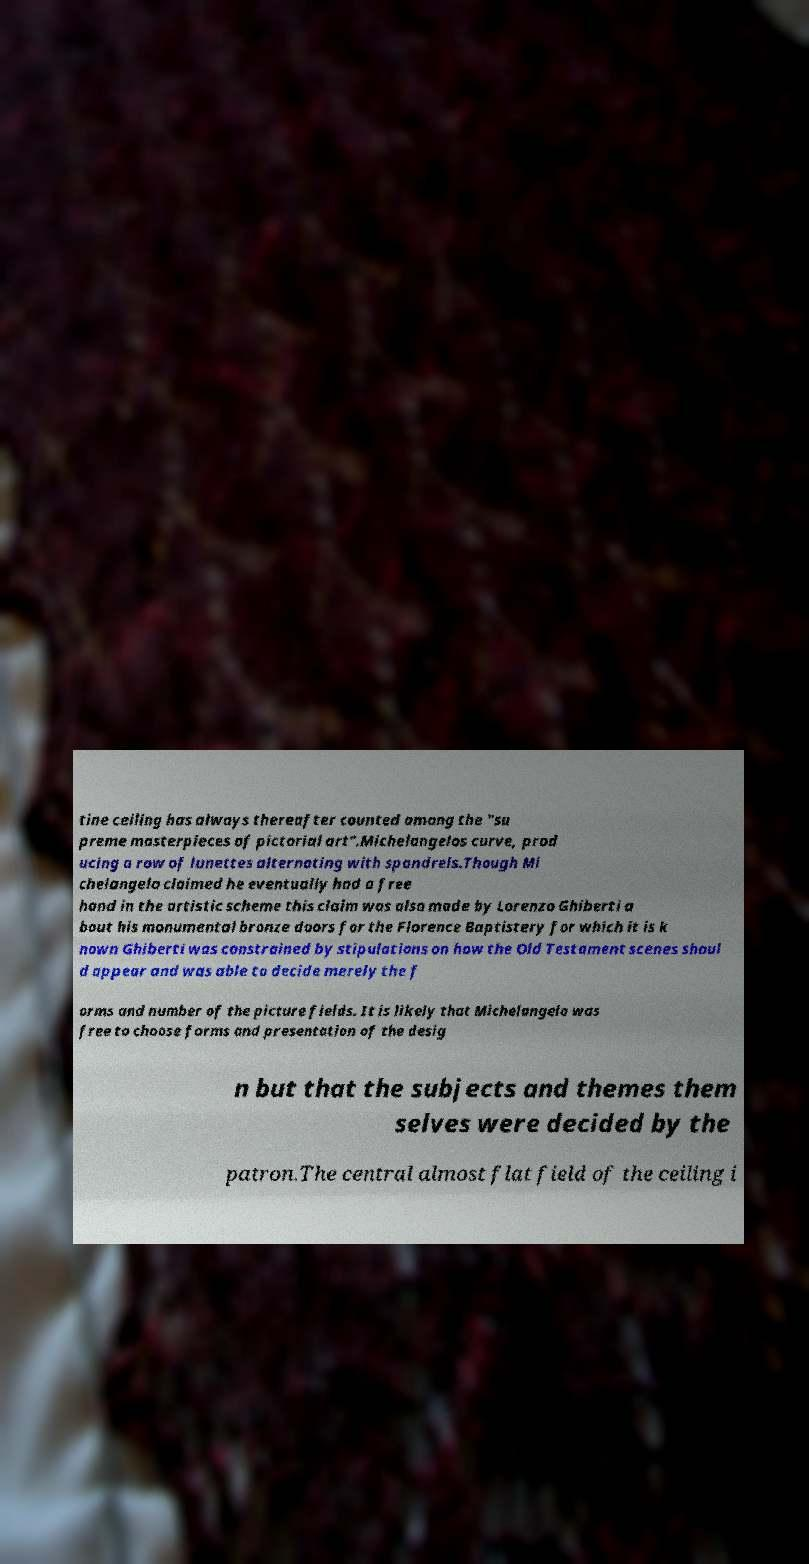Can you accurately transcribe the text from the provided image for me? tine ceiling has always thereafter counted among the "su preme masterpieces of pictorial art".Michelangelos curve, prod ucing a row of lunettes alternating with spandrels.Though Mi chelangelo claimed he eventually had a free hand in the artistic scheme this claim was also made by Lorenzo Ghiberti a bout his monumental bronze doors for the Florence Baptistery for which it is k nown Ghiberti was constrained by stipulations on how the Old Testament scenes shoul d appear and was able to decide merely the f orms and number of the picture fields. It is likely that Michelangelo was free to choose forms and presentation of the desig n but that the subjects and themes them selves were decided by the patron.The central almost flat field of the ceiling i 